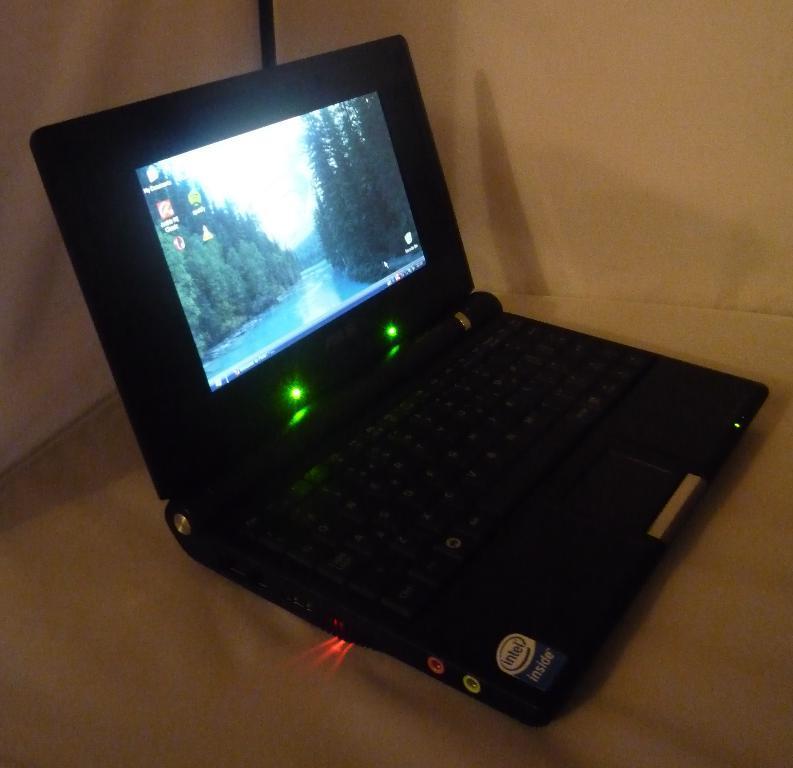How would you summarize this image in a sentence or two? In this picture I can see a black color laptop and a white color background. 